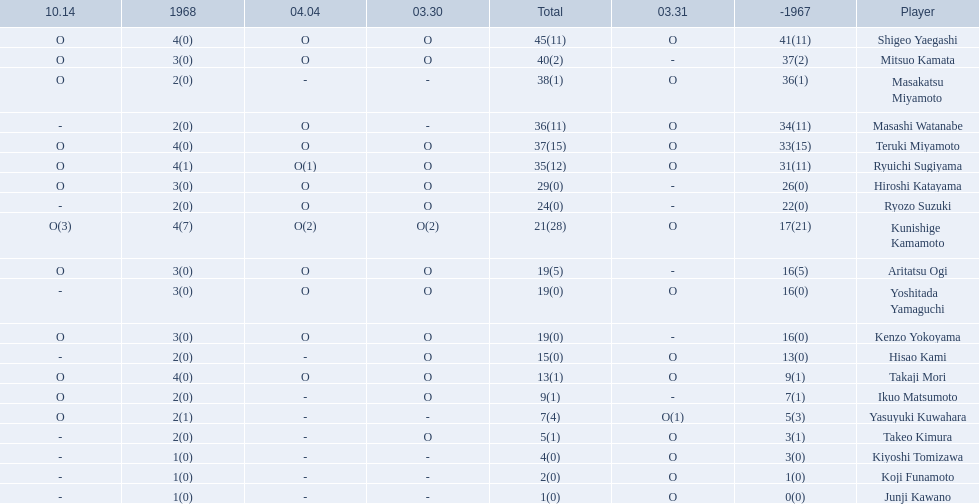Who are all of the players? Shigeo Yaegashi, Mitsuo Kamata, Masakatsu Miyamoto, Masashi Watanabe, Teruki Miyamoto, Ryuichi Sugiyama, Hiroshi Katayama, Ryozo Suzuki, Kunishige Kamamoto, Aritatsu Ogi, Yoshitada Yamaguchi, Kenzo Yokoyama, Hisao Kami, Takaji Mori, Ikuo Matsumoto, Yasuyuki Kuwahara, Takeo Kimura, Kiyoshi Tomizawa, Koji Funamoto, Junji Kawano. How many points did they receive? 45(11), 40(2), 38(1), 36(11), 37(15), 35(12), 29(0), 24(0), 21(28), 19(5), 19(0), 19(0), 15(0), 13(1), 9(1), 7(4), 5(1), 4(0), 2(0), 1(0). What about just takaji mori and junji kawano? 13(1), 1(0). Of the two, who had more points? Takaji Mori. 